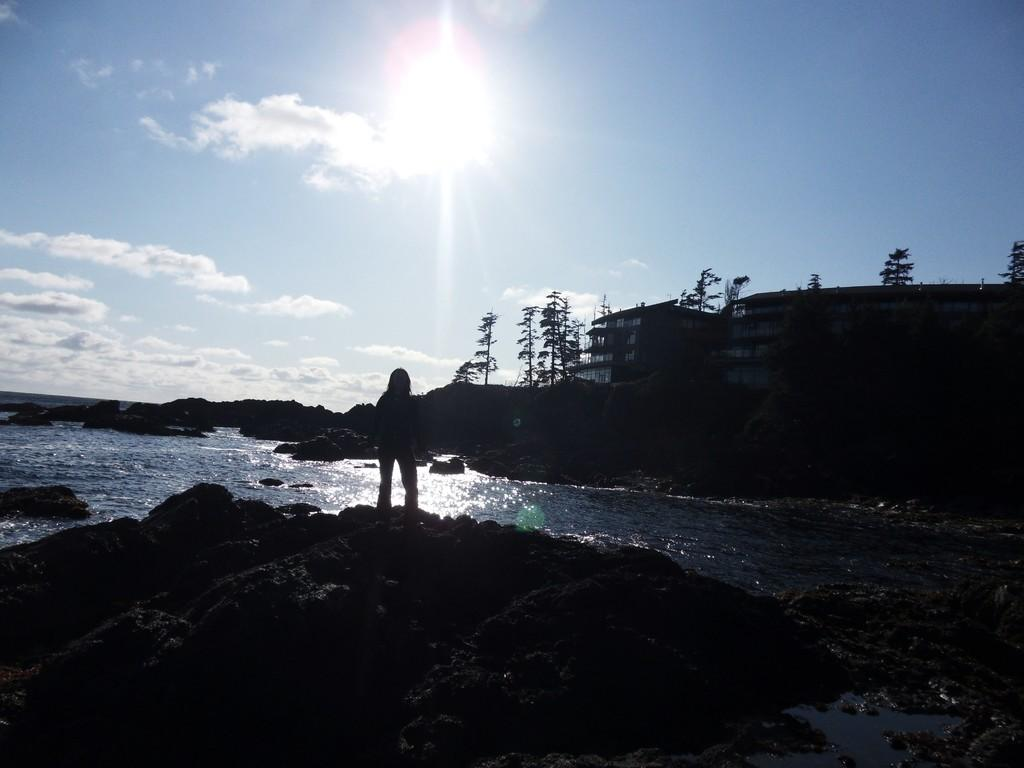What is the main subject in the image? There is a person standing in the image. What can be seen in the background of the image? There is a building and many trees in the image. What natural element is visible in the image? There is water visible in the image. What type of ground surface is present in the image? There are stones in the image. How would you describe the sky in the image? The sky is cloudy and pale blue, and the sun is visible. How many pigs are visible in the image? There are no pigs present in the image. What type of twig is the person holding in the image? There is no twig visible in the image. 